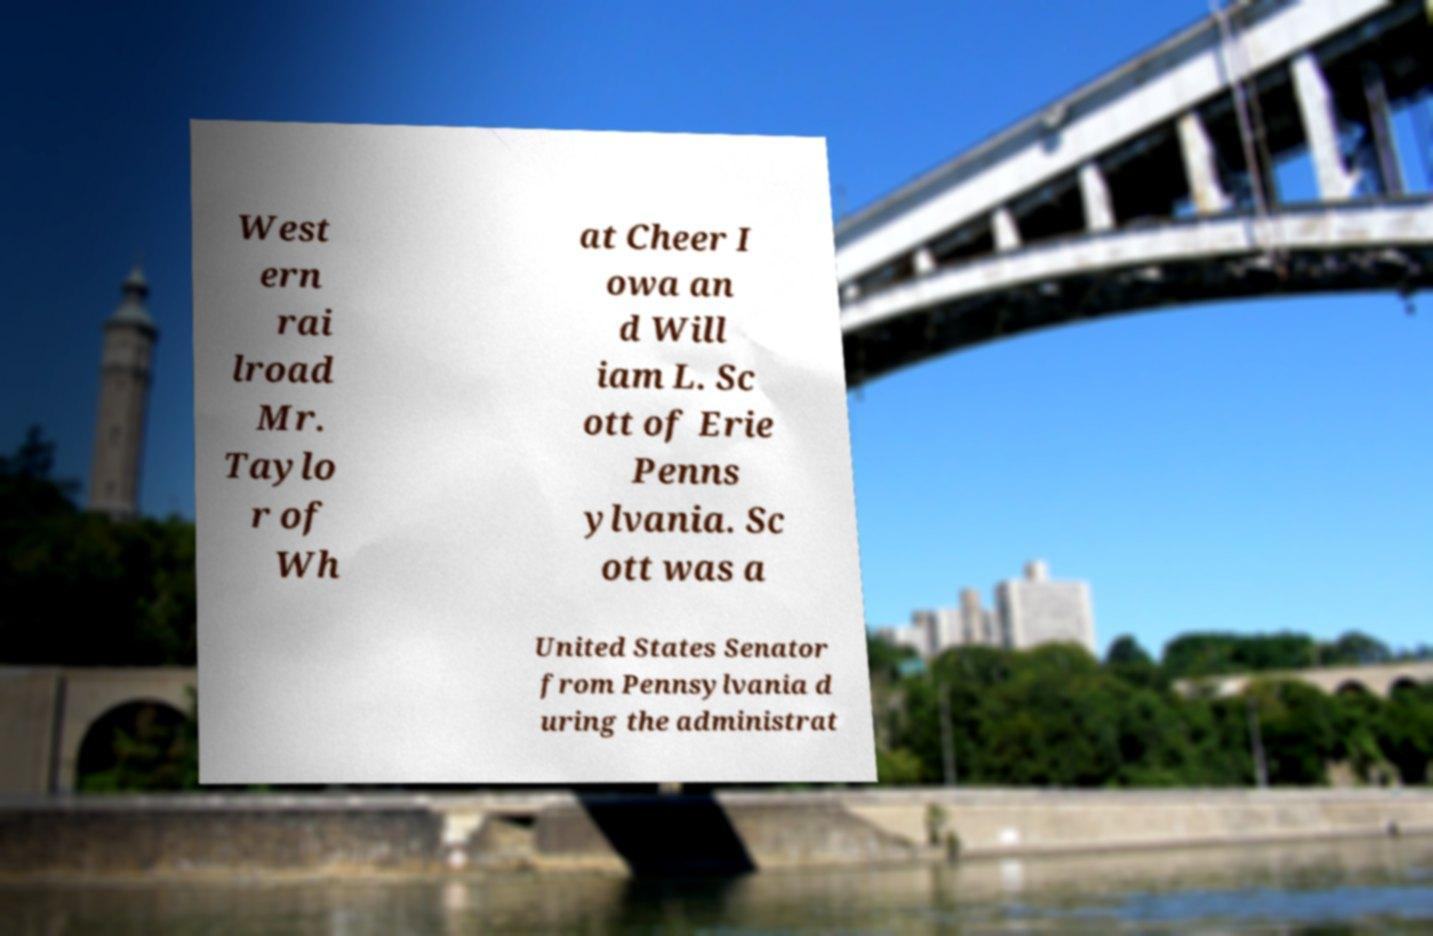Please identify and transcribe the text found in this image. West ern rai lroad Mr. Taylo r of Wh at Cheer I owa an d Will iam L. Sc ott of Erie Penns ylvania. Sc ott was a United States Senator from Pennsylvania d uring the administrat 